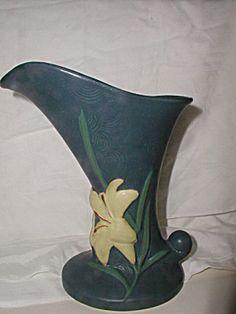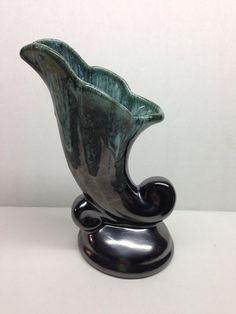The first image is the image on the left, the second image is the image on the right. For the images shown, is this caption "The right image features a matched pair of vases." true? Answer yes or no. No. The first image is the image on the left, the second image is the image on the right. Evaluate the accuracy of this statement regarding the images: "In one image, a vase with floral petal top design and scroll at the bottom is positioned in the center of a doily.". Is it true? Answer yes or no. No. 